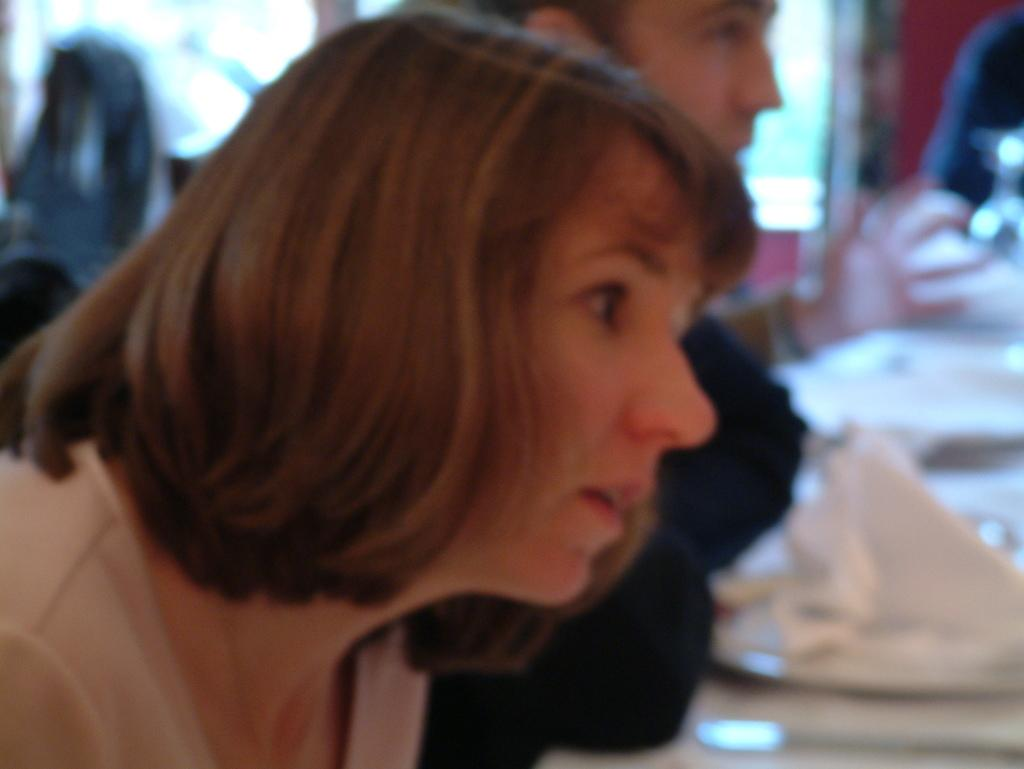Who is present in the image? There is a woman in the picture. Can you describe the person beside the woman? There is a person beside the woman, but their appearance or characteristics are not specified in the facts. What can be seen in the background of the image? There are other objects in the background of the image, but their nature or details are not provided. What type of bait is the woman using in the image? There is no mention of bait or fishing in the image, so it cannot be determined from the facts. 